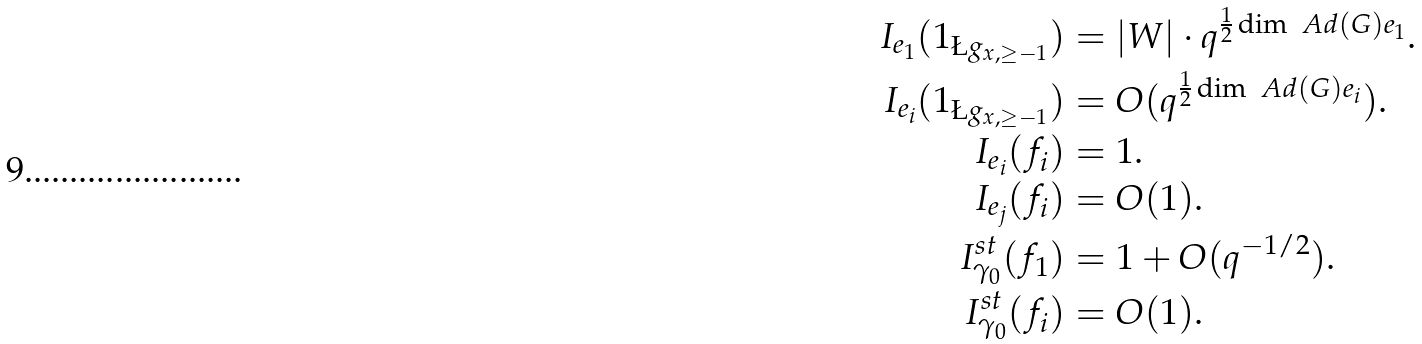<formula> <loc_0><loc_0><loc_500><loc_500>I _ { e _ { 1 } } ( 1 _ { \L g _ { x , \geq - 1 } } ) & = | W | \cdot q ^ { \frac { 1 } { 2 } \dim \ A d ( G ) e _ { 1 } } . \\ I _ { e _ { i } } ( 1 _ { \L g _ { x , \geq - 1 } } ) & = O ( q ^ { \frac { 1 } { 2 } \dim \ A d ( G ) e _ { i } } ) . \\ I _ { e _ { i } } ( f _ { i } ) & = 1 . \\ I _ { e _ { j } } ( f _ { i } ) & = O ( 1 ) . \\ I _ { \gamma _ { 0 } } ^ { s t } ( f _ { 1 } ) & = 1 + O ( q ^ { - 1 / 2 } ) . \\ I _ { \gamma _ { 0 } } ^ { s t } ( f _ { i } ) & = O ( 1 ) .</formula> 